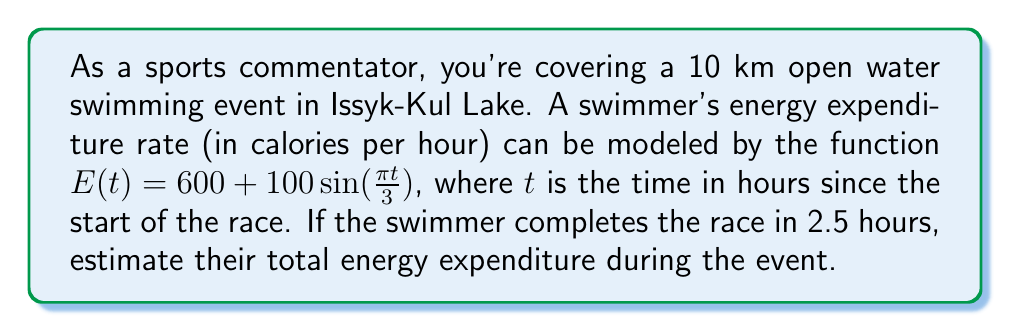Show me your answer to this math problem. To solve this problem, we need to integrate the energy expenditure rate function over the duration of the race. Let's break it down step-by-step:

1) The energy expenditure rate is given by:
   $E(t) = 600 + 100\sin(\frac{\pi t}{3})$ calories per hour

2) To find the total energy expenditure, we need to integrate this function from $t=0$ to $t=2.5$ hours:

   $$\text{Total Energy} = \int_0^{2.5} E(t) dt = \int_0^{2.5} (600 + 100\sin(\frac{\pi t}{3})) dt$$

3) Let's split this integral:

   $$\int_0^{2.5} 600 dt + \int_0^{2.5} 100\sin(\frac{\pi t}{3}) dt$$

4) Integrate the first part:
   
   $$600t \bigg|_0^{2.5} = 600 \cdot 2.5 - 600 \cdot 0 = 1500$$

5) For the second part, we use the substitution $u = \frac{\pi t}{3}$:
   
   $$100 \cdot \frac{3}{\pi} \int_0^{\frac{5\pi}{6}} \sin(u) du = -\frac{300}{\pi} \cos(u) \bigg|_0^{\frac{5\pi}{6}}$$

6) Evaluate:
   
   $$-\frac{300}{\pi} (\cos(\frac{5\pi}{6}) - \cos(0)) = -\frac{300}{\pi} (-\frac{\sqrt{3}}{2} - 1) = \frac{300}{\pi} (\frac{\sqrt{3}}{2} + 1)$$

7) Add the results from steps 4 and 6:

   $$\text{Total Energy} = 1500 + \frac{300}{\pi} (\frac{\sqrt{3}}{2} + 1) \approx 1659.6$$

Therefore, the swimmer expends approximately 1660 calories during the 2.5-hour race.
Answer: 1660 calories 